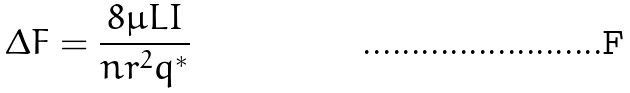<formula> <loc_0><loc_0><loc_500><loc_500>\Delta F = \frac { 8 \mu L I } { n r ^ { 2 } q ^ { * } }</formula> 